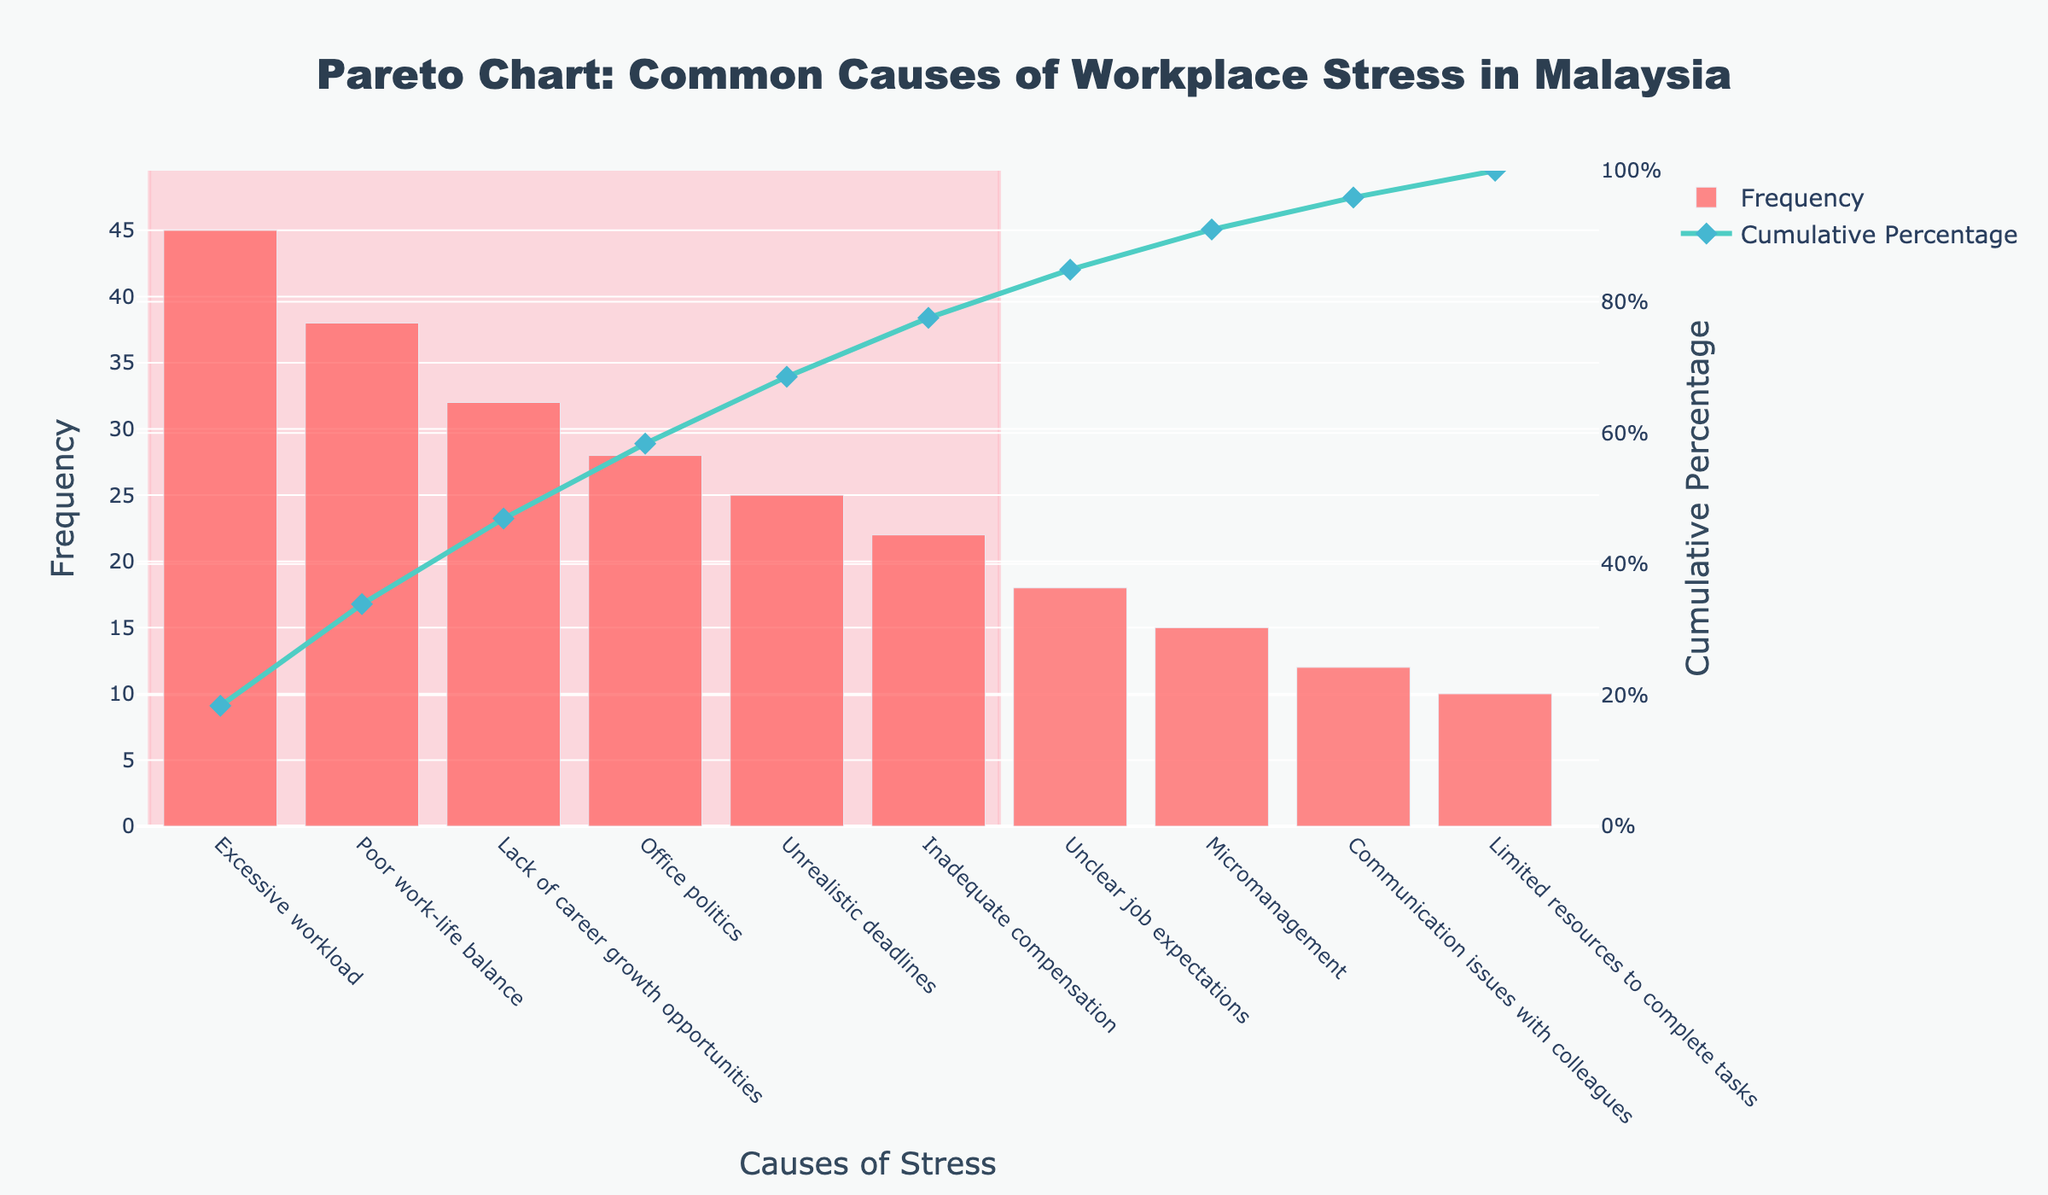How many causes of workplace stress are listed in the figure? The figure lists each cause of workplace stress on the x-axis. Counting the items on the x-axis gives the total number of causes.
Answer: 10 What is the cause of workplace stress with the highest frequency? The cause with the highest frequency is displayed as the tallest bar in the bar chart. This corresponds to "Excessive workload."
Answer: Excessive workload Where is the 80% cumulative percentage line located in the figure? The 80% cumulative percentage line is indicated by an annotation along the y2-axis (right-side), usually marked with an 80% label.
Answer: Right-side y-axis, at 80% Which cause of workplace stress contributes just below 30% of the cumulative percentage? Look at the cumulative percentage line. Identify the point closest to but less than 30% on the y2-axis. The corresponding x-axis label is "Lack of career growth opportunities."
Answer: Lack of career growth opportunities How many causes contribute to the first 80% of the cumulative percentage? Identify the portion of the cumulative percentage line where it reaches or exceeds 80% and count the number of causes (bars) from the left up to that point.
Answer: 5 What is the cumulative percentage at "Office politics"? Find "Office politics" on the x-axis, then look at the corresponding value on the cumulative percentage line on the y2-axis (right side).
Answer: Approximately 73% How does the frequency of "Poor work-life balance" compare with "Micromanagement"? Compare the heights of the bars for "Poor work-life balance" and "Micromanagement." "Poor work-life balance" has a higher frequency than "Micromanagement."
Answer: Poor work-life balance has a higher frequency than Micromanagement What is the cumulative percentage after the first three causes? Sum the percentages of the first three points on the cumulative percentage line. For "Excessive workload," "Poor work-life balance," and "Lack of career growth opportunities," add the respective values. This gives approximately 27.1% + 50.6% = 77.7%.
Answer: Approximately 77.7% What colors represent the frequency bars and the cumulative percentage line? The frequency bars are colored in a shade of red, while the cumulative percentage is shown as a teal line with diamond markers.
Answer: Red for frequency bars, teal for cumulative percentage line Which cause has the lowest frequency and how much is it? Identify the shortest bar in the bar chart, which corresponds to "Limited resources to complete tasks," and note its frequency value.
Answer: Limited resources to complete tasks, 10 